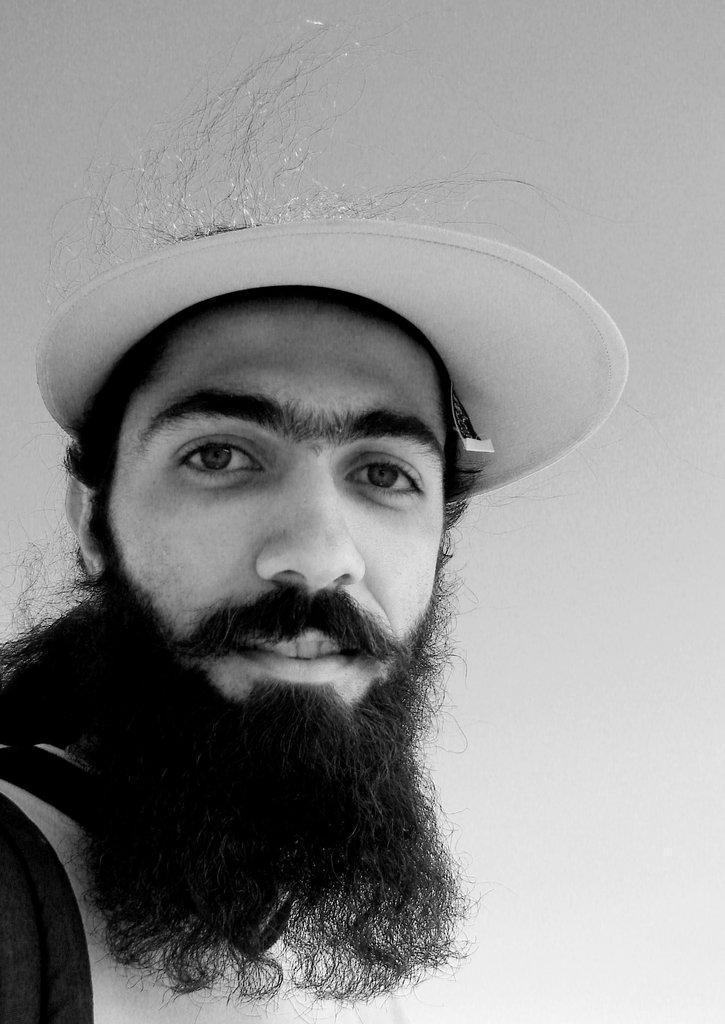Describe this image in one or two sentences. This is a black and white image. On the left side, there is a person, wearing a cap and smiling. And the background is white in color. 